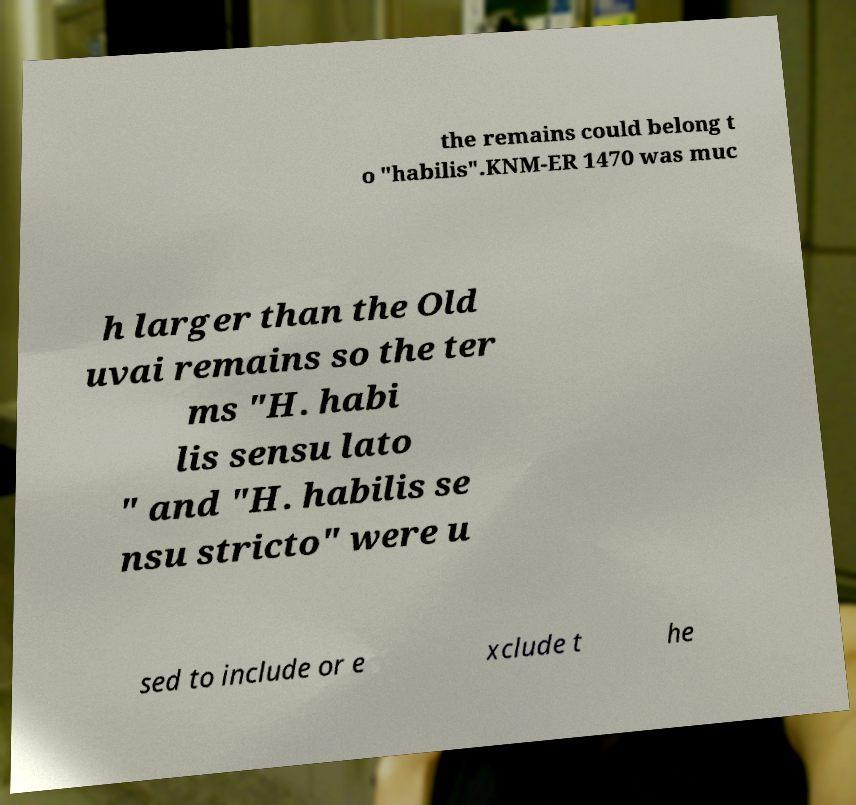What messages or text are displayed in this image? I need them in a readable, typed format. the remains could belong t o "habilis".KNM-ER 1470 was muc h larger than the Old uvai remains so the ter ms "H. habi lis sensu lato " and "H. habilis se nsu stricto" were u sed to include or e xclude t he 